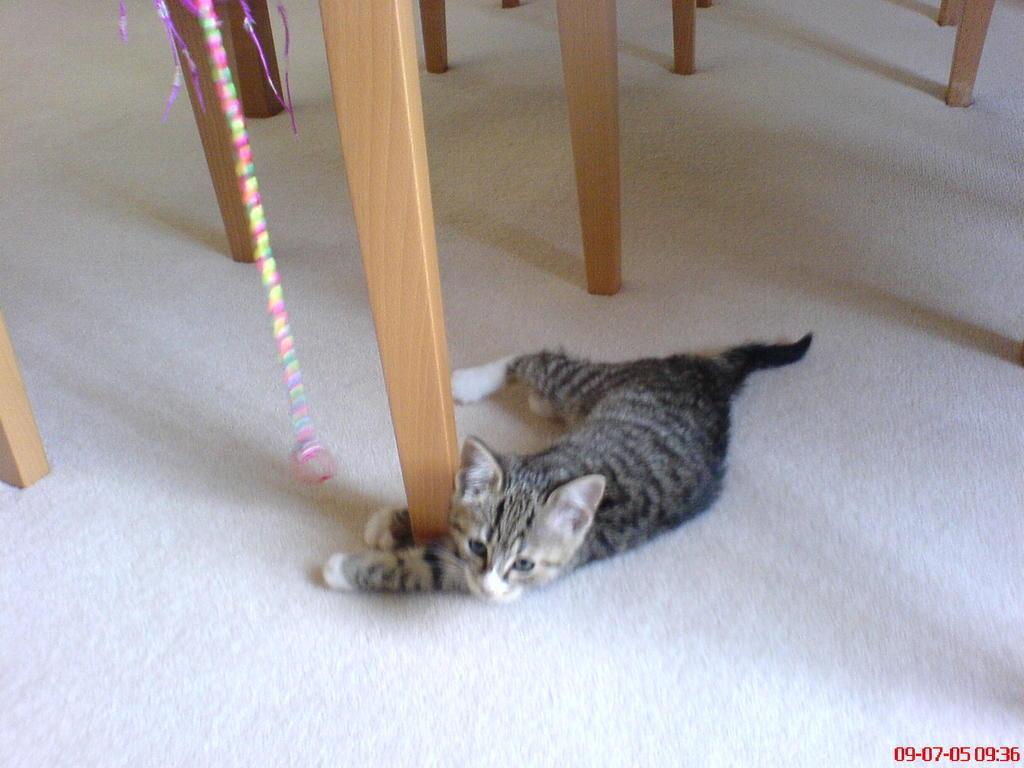How would you summarize this image in a sentence or two? In this image there is a cat, there is a mat towards the bottom of the image, there are numbers towards the bottom of the image, there is an object towards the top of the image, there are wooden objects towards the top of the image, there is a wooden object towards the left of the image. 